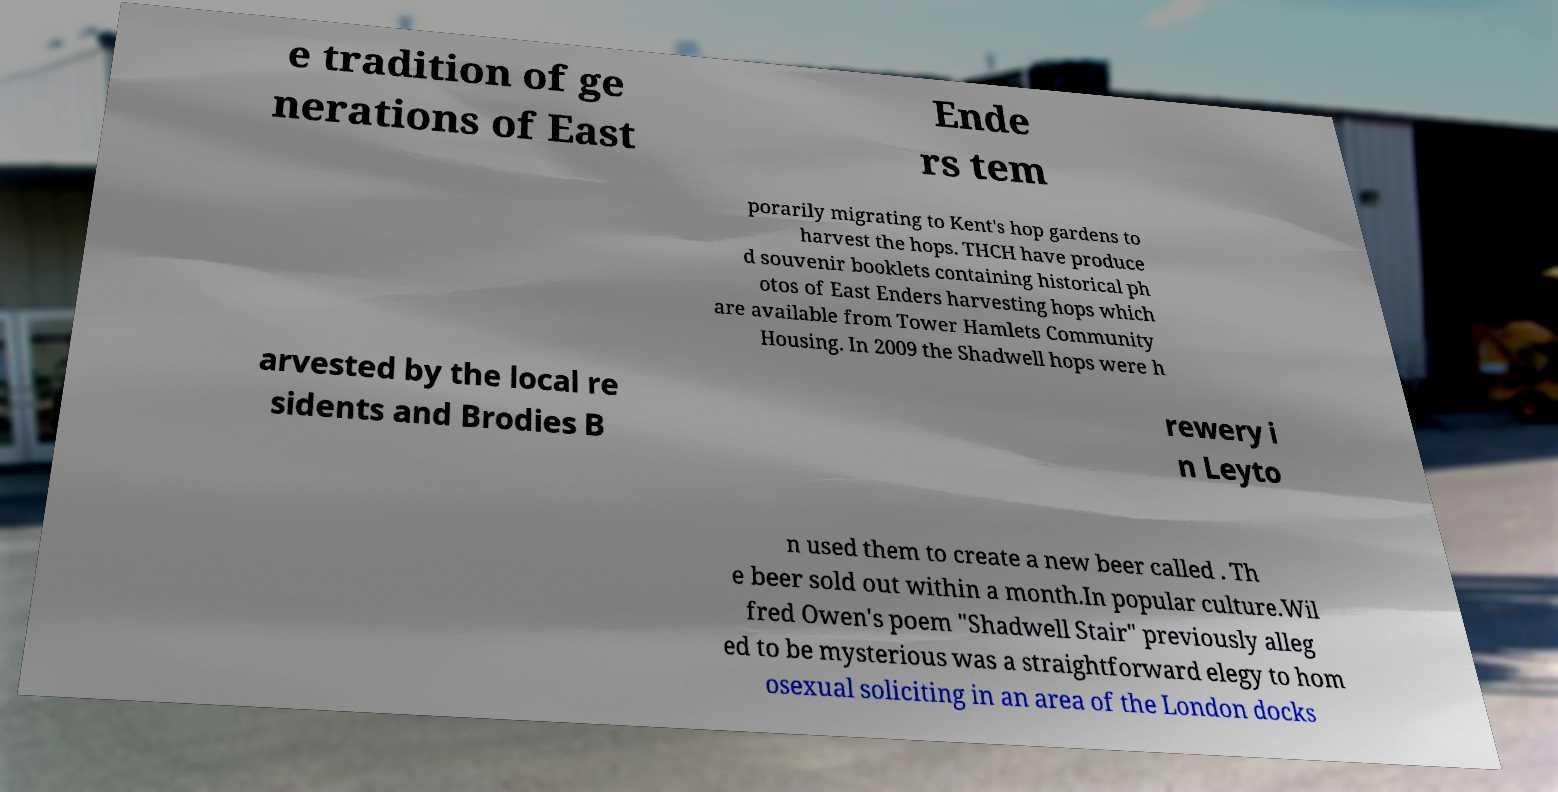Can you accurately transcribe the text from the provided image for me? e tradition of ge nerations of East Ende rs tem porarily migrating to Kent's hop gardens to harvest the hops. THCH have produce d souvenir booklets containing historical ph otos of East Enders harvesting hops which are available from Tower Hamlets Community Housing. In 2009 the Shadwell hops were h arvested by the local re sidents and Brodies B rewery i n Leyto n used them to create a new beer called . Th e beer sold out within a month.In popular culture.Wil fred Owen's poem "Shadwell Stair" previously alleg ed to be mysterious was a straightforward elegy to hom osexual soliciting in an area of the London docks 